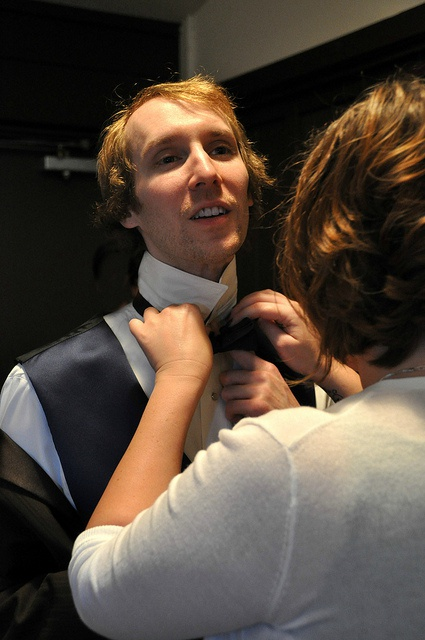Describe the objects in this image and their specific colors. I can see people in black, gray, darkgray, and tan tones, people in black, maroon, and gray tones, and tie in black, maroon, and brown tones in this image. 